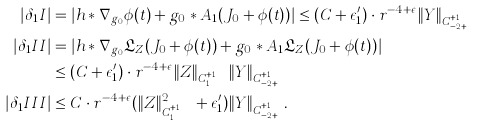Convert formula to latex. <formula><loc_0><loc_0><loc_500><loc_500>| \delta _ { 1 } I | & = | h * \nabla _ { g _ { 0 } } \phi ( t ) + g _ { 0 } * A _ { 1 } ( J _ { 0 } + \phi ( t ) ) | \leq ( C + \epsilon _ { 1 } ^ { \prime } ) \cdot r ^ { - 4 + \epsilon } \| Y \| _ { C ^ { k + 1 , \alpha } _ { - 2 + \epsilon } } \\ | \delta _ { 1 } I I | & = | h * \nabla _ { g _ { 0 } } \mathfrak { L } _ { Z } ( J _ { 0 } + \phi ( t ) ) + g _ { 0 } * A _ { 1 } \mathfrak { L } _ { Z } ( J _ { 0 } + \phi ( t ) ) | \\ & \leq ( C + \epsilon _ { 1 } ^ { \prime } ) \cdot r ^ { - 4 + \epsilon } \| Z \| _ { C ^ { k + 1 , \alpha } _ { 1 } } \| Y \| _ { C ^ { k + 1 , \alpha } _ { - 2 + \epsilon } } \\ | \delta _ { 1 } I I I | & \leq C \cdot r ^ { - 4 + \epsilon } ( \| Z \| _ { C ^ { k + 1 , \alpha } _ { 1 } } ^ { 2 } + \epsilon _ { 1 } ^ { \prime } ) \| Y \| _ { C ^ { k + 1 , \alpha } _ { - 2 + \epsilon } } .</formula> 